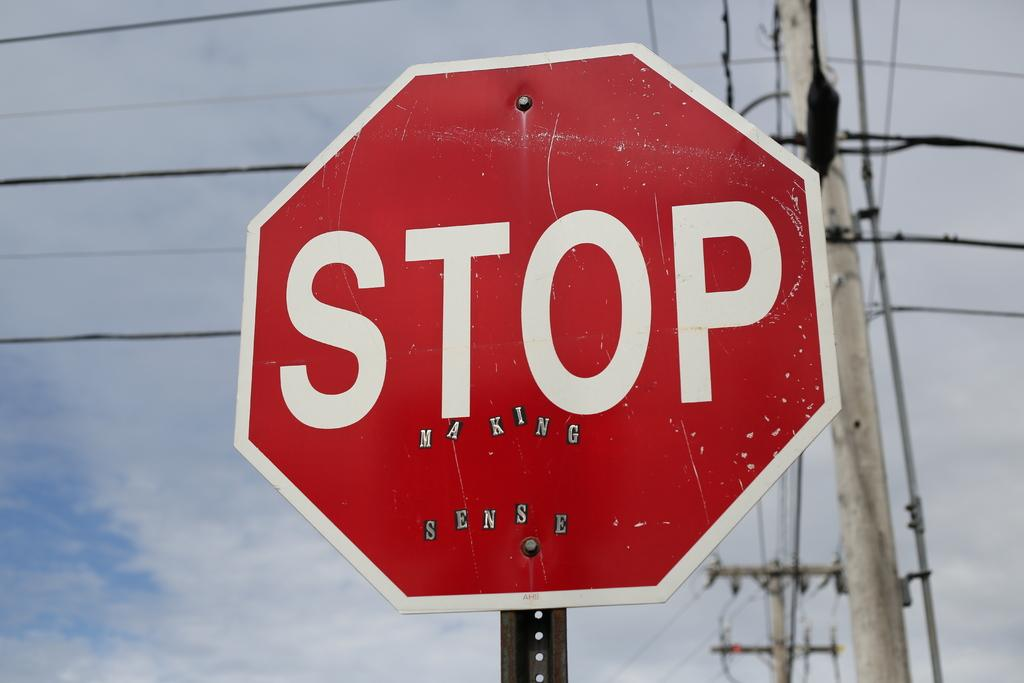<image>
Summarize the visual content of the image. The red stop is shown infront of telephone poles. 